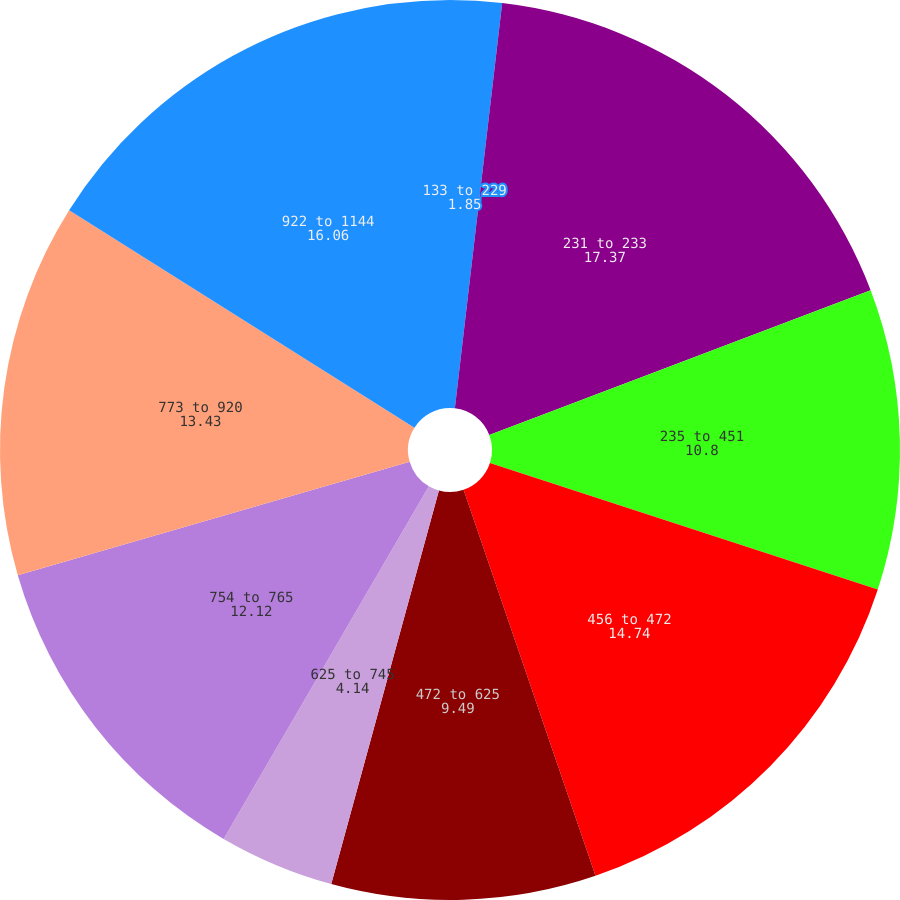Convert chart. <chart><loc_0><loc_0><loc_500><loc_500><pie_chart><fcel>133 to 229<fcel>231 to 233<fcel>235 to 451<fcel>456 to 472<fcel>472 to 625<fcel>625 to 745<fcel>754 to 765<fcel>773 to 920<fcel>922 to 1144<nl><fcel>1.85%<fcel>17.37%<fcel>10.8%<fcel>14.74%<fcel>9.49%<fcel>4.14%<fcel>12.12%<fcel>13.43%<fcel>16.06%<nl></chart> 